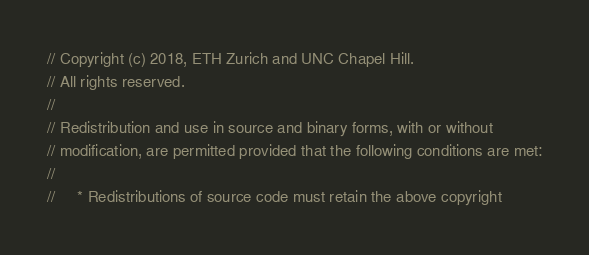<code> <loc_0><loc_0><loc_500><loc_500><_C++_>// Copyright (c) 2018, ETH Zurich and UNC Chapel Hill.
// All rights reserved.
//
// Redistribution and use in source and binary forms, with or without
// modification, are permitted provided that the following conditions are met:
//
//     * Redistributions of source code must retain the above copyright</code> 